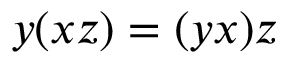Convert formula to latex. <formula><loc_0><loc_0><loc_500><loc_500>y ( x z ) = ( y x ) z</formula> 